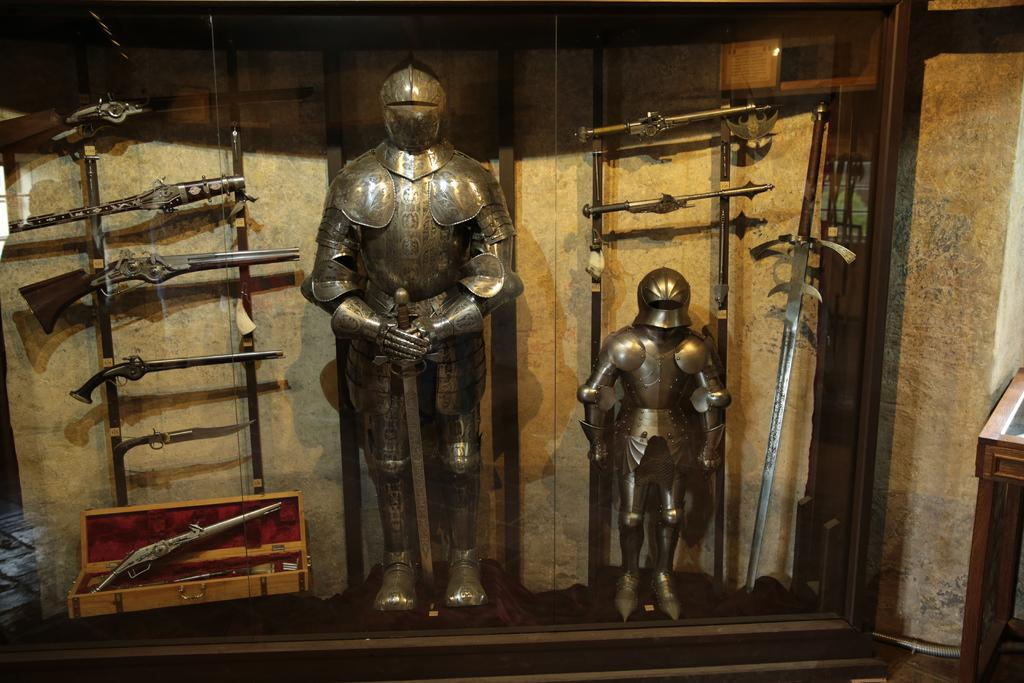What type of objects can be seen in the image? There are statues and weapons in the image. What else is present in the image besides statues and weapons? There is a box in the image. What can be seen in the background of the image? There is a wall in the background of the image. What color is the sock on the statue's foot in the image? There is no sock present on any statue's foot in the image. 